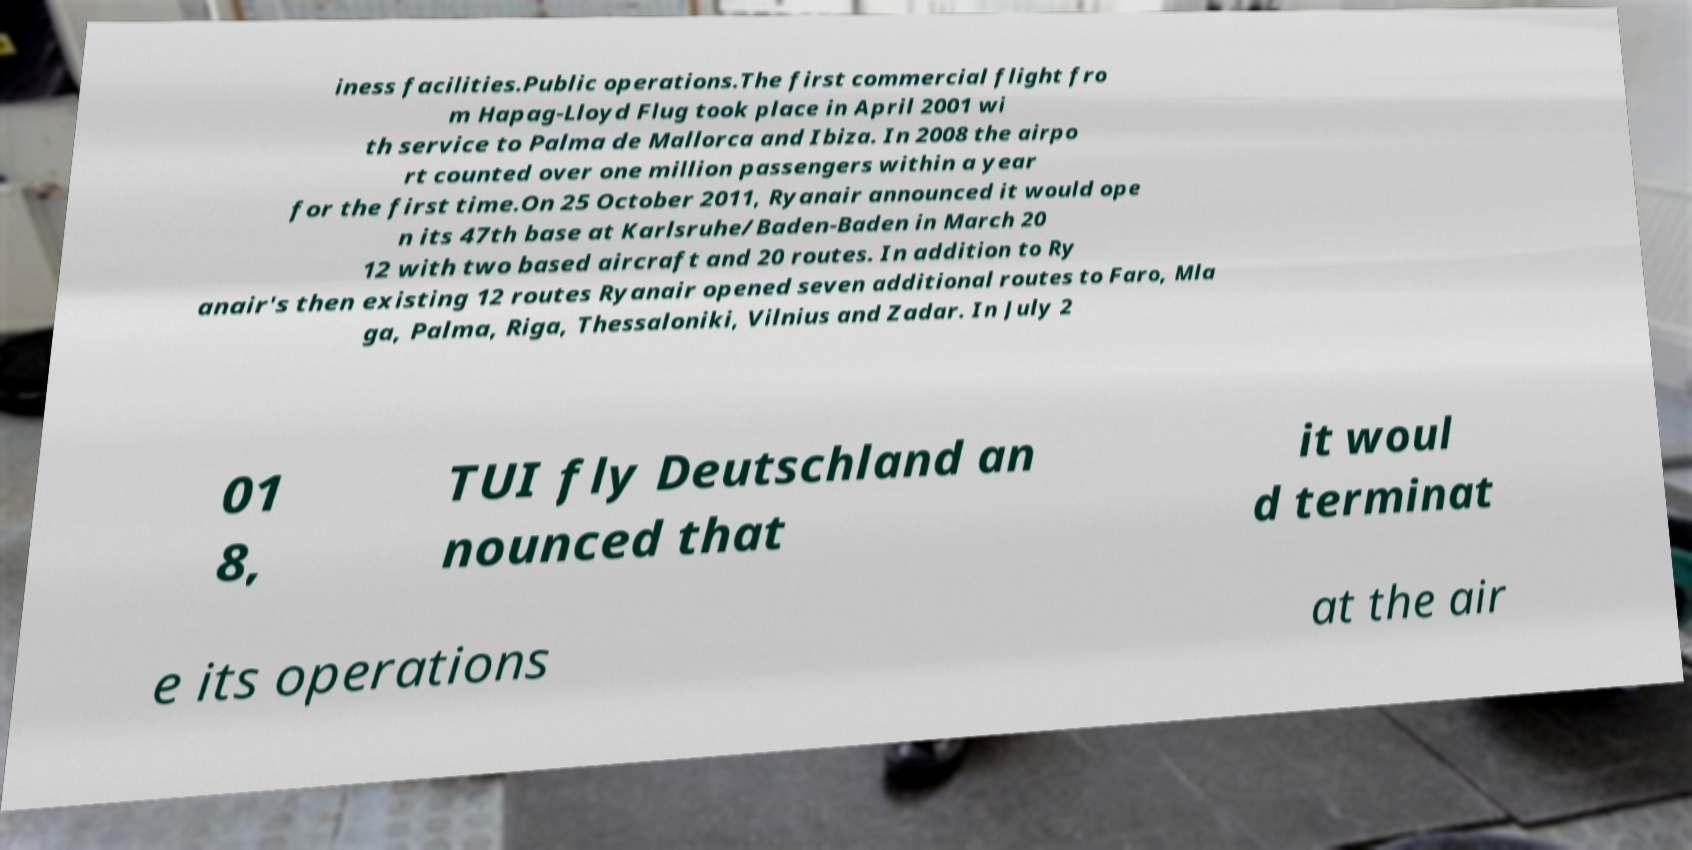Can you read and provide the text displayed in the image?This photo seems to have some interesting text. Can you extract and type it out for me? iness facilities.Public operations.The first commercial flight fro m Hapag-Lloyd Flug took place in April 2001 wi th service to Palma de Mallorca and Ibiza. In 2008 the airpo rt counted over one million passengers within a year for the first time.On 25 October 2011, Ryanair announced it would ope n its 47th base at Karlsruhe/Baden-Baden in March 20 12 with two based aircraft and 20 routes. In addition to Ry anair's then existing 12 routes Ryanair opened seven additional routes to Faro, Mla ga, Palma, Riga, Thessaloniki, Vilnius and Zadar. In July 2 01 8, TUI fly Deutschland an nounced that it woul d terminat e its operations at the air 